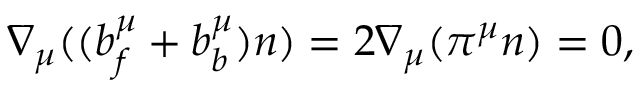Convert formula to latex. <formula><loc_0><loc_0><loc_500><loc_500>\nabla _ { \mu } ( ( b _ { f } ^ { \mu } + b _ { b } ^ { \mu } ) n ) = 2 \nabla _ { \mu } ( \pi ^ { \mu } n ) = 0 ,</formula> 